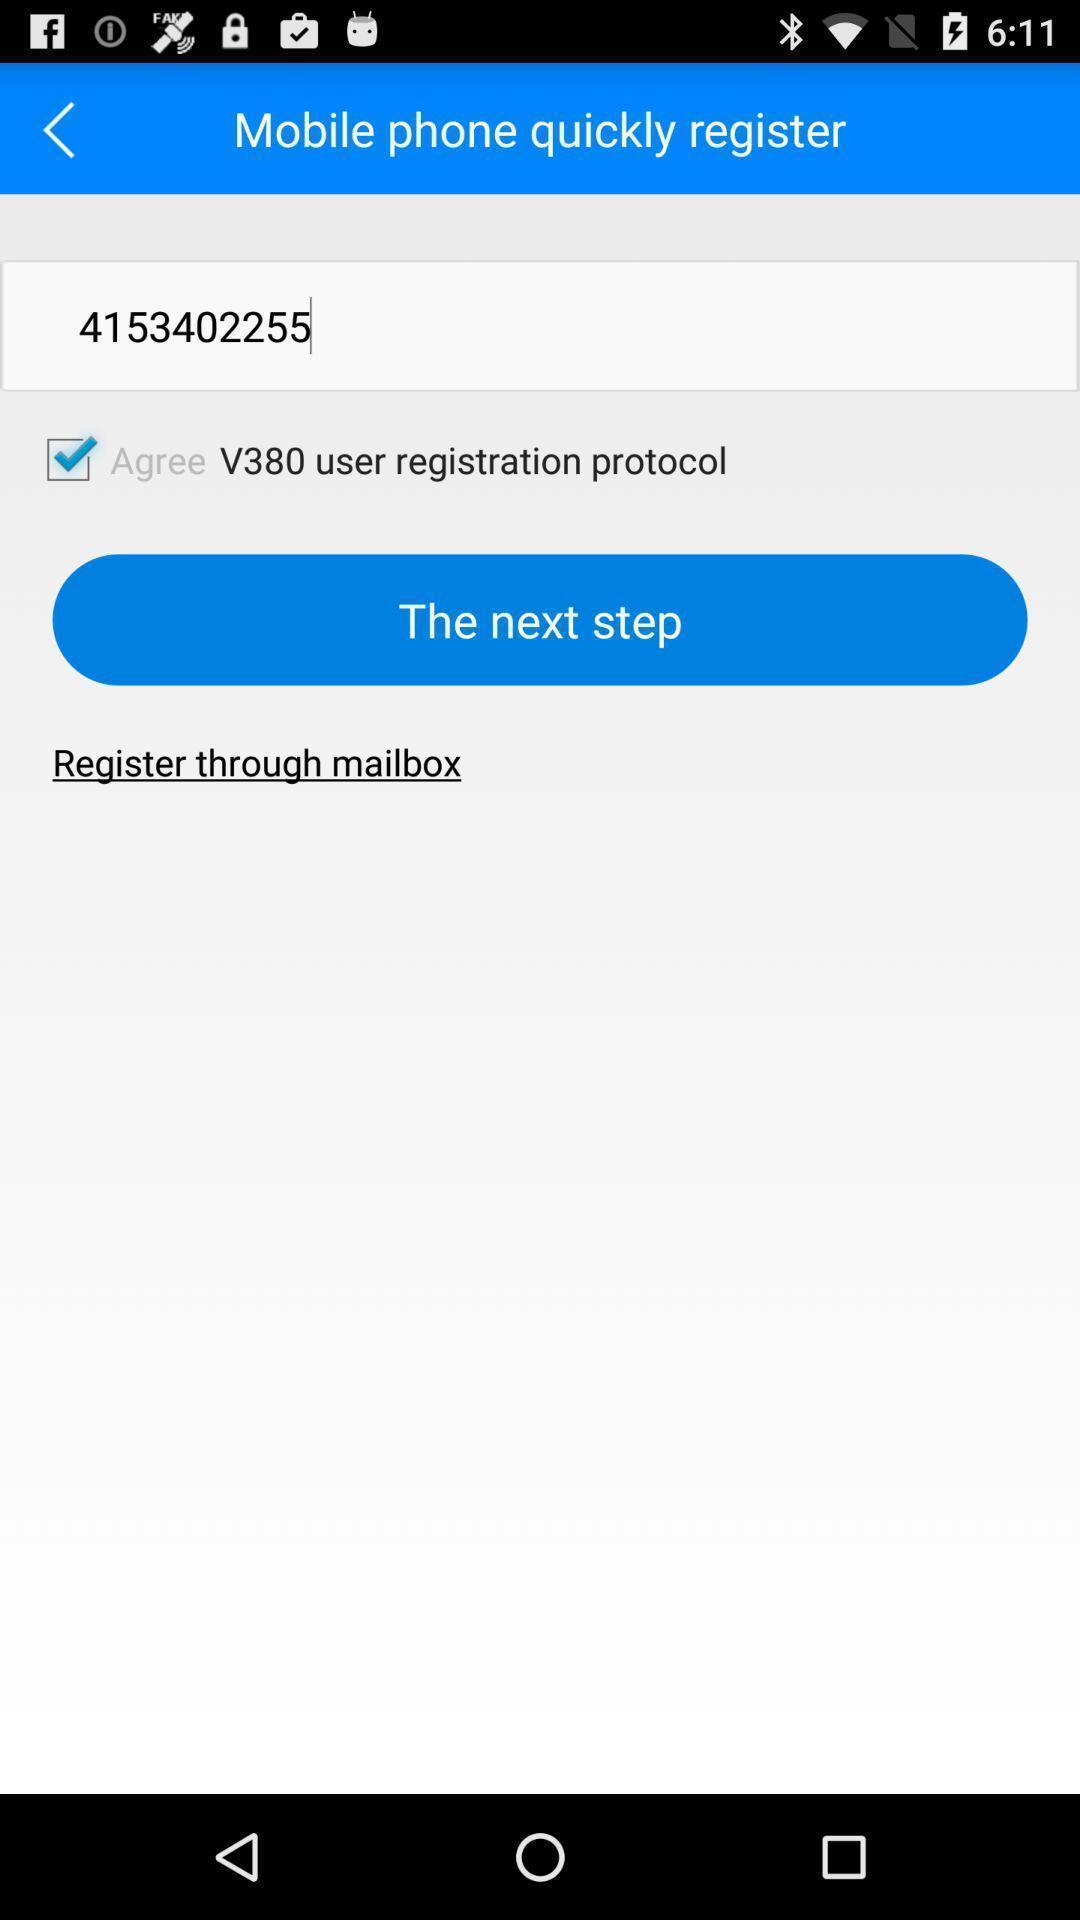Summarize the main components in this picture. Page displaying to register with next option. 